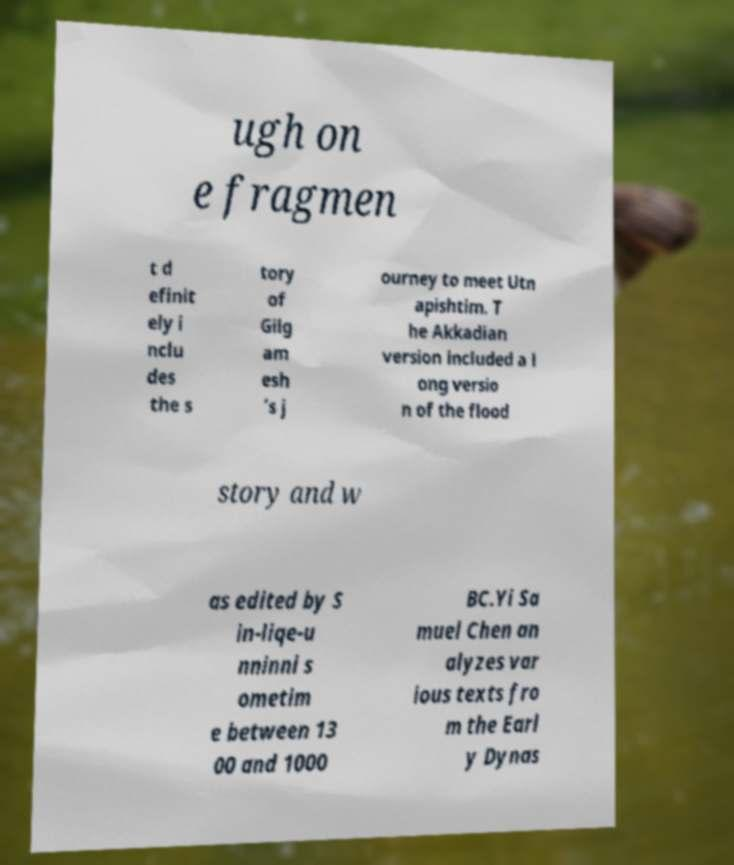Please identify and transcribe the text found in this image. ugh on e fragmen t d efinit ely i nclu des the s tory of Gilg am esh ’s j ourney to meet Utn apishtim. T he Akkadian version included a l ong versio n of the flood story and w as edited by S in-liqe-u nninni s ometim e between 13 00 and 1000 BC.Yi Sa muel Chen an alyzes var ious texts fro m the Earl y Dynas 